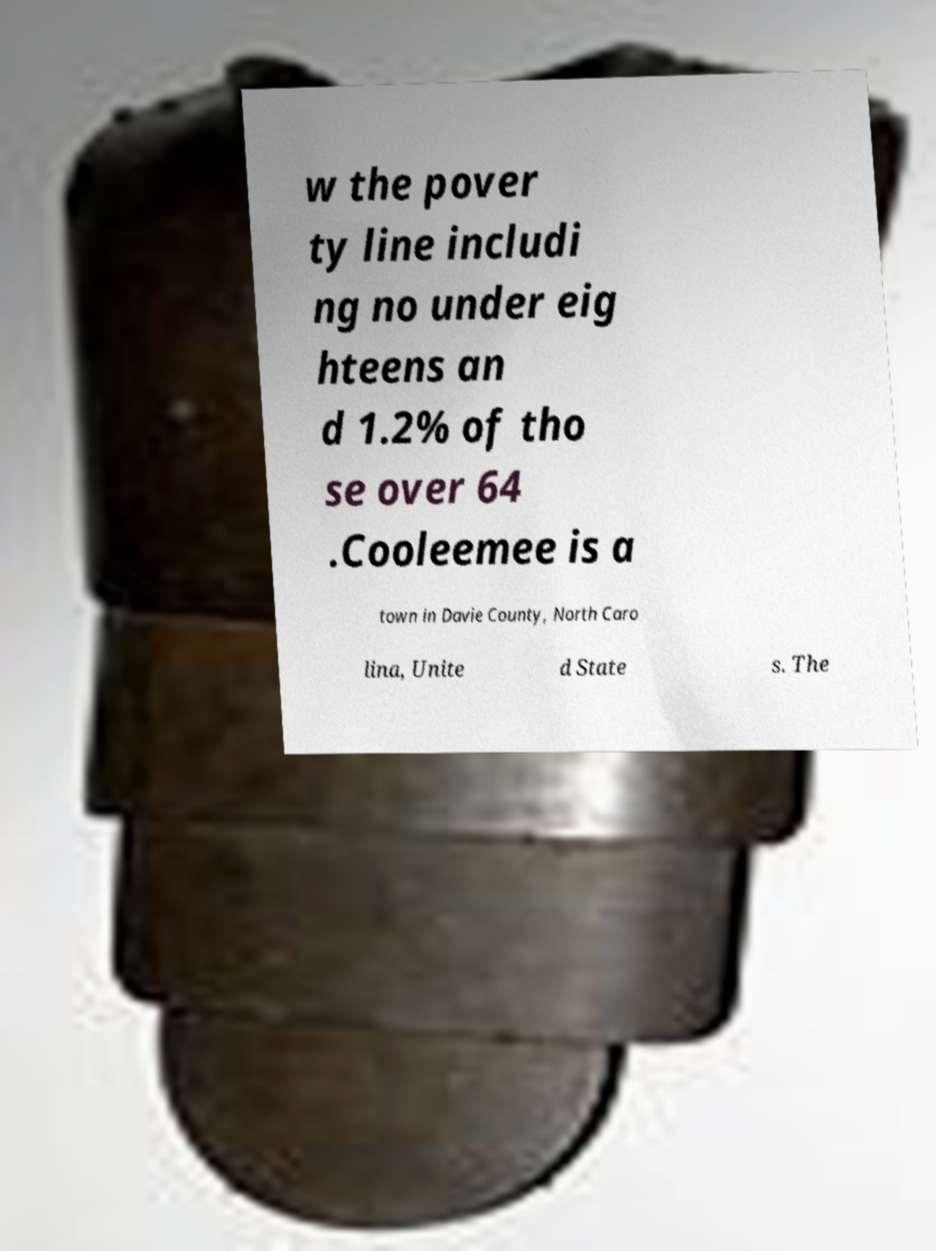Please read and relay the text visible in this image. What does it say? w the pover ty line includi ng no under eig hteens an d 1.2% of tho se over 64 .Cooleemee is a town in Davie County, North Caro lina, Unite d State s. The 